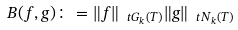<formula> <loc_0><loc_0><loc_500><loc_500>B ( f , g ) \colon = \| f \| _ { \ t G _ { k } ( T ) } \| g \| _ { \ t N _ { k } ( T ) }</formula> 